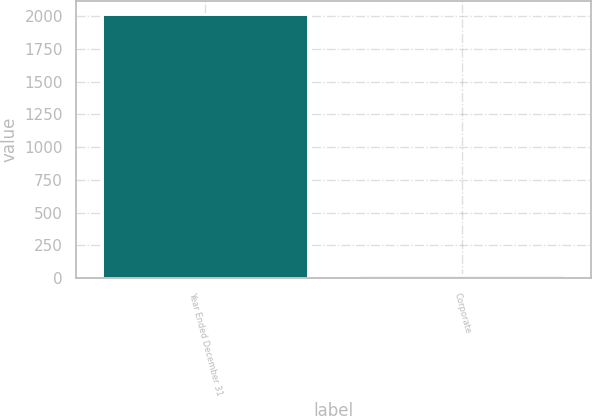Convert chart to OTSL. <chart><loc_0><loc_0><loc_500><loc_500><bar_chart><fcel>Year Ended December 31<fcel>Corporate<nl><fcel>2014<fcel>24<nl></chart> 